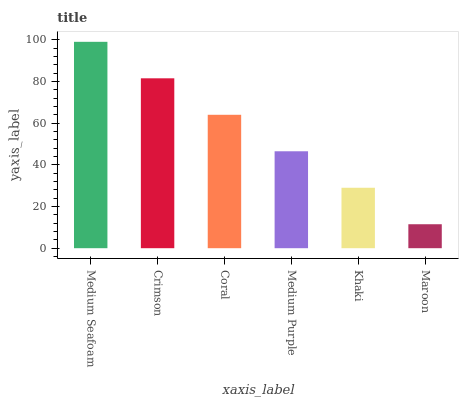Is Maroon the minimum?
Answer yes or no. Yes. Is Medium Seafoam the maximum?
Answer yes or no. Yes. Is Crimson the minimum?
Answer yes or no. No. Is Crimson the maximum?
Answer yes or no. No. Is Medium Seafoam greater than Crimson?
Answer yes or no. Yes. Is Crimson less than Medium Seafoam?
Answer yes or no. Yes. Is Crimson greater than Medium Seafoam?
Answer yes or no. No. Is Medium Seafoam less than Crimson?
Answer yes or no. No. Is Coral the high median?
Answer yes or no. Yes. Is Medium Purple the low median?
Answer yes or no. Yes. Is Khaki the high median?
Answer yes or no. No. Is Coral the low median?
Answer yes or no. No. 